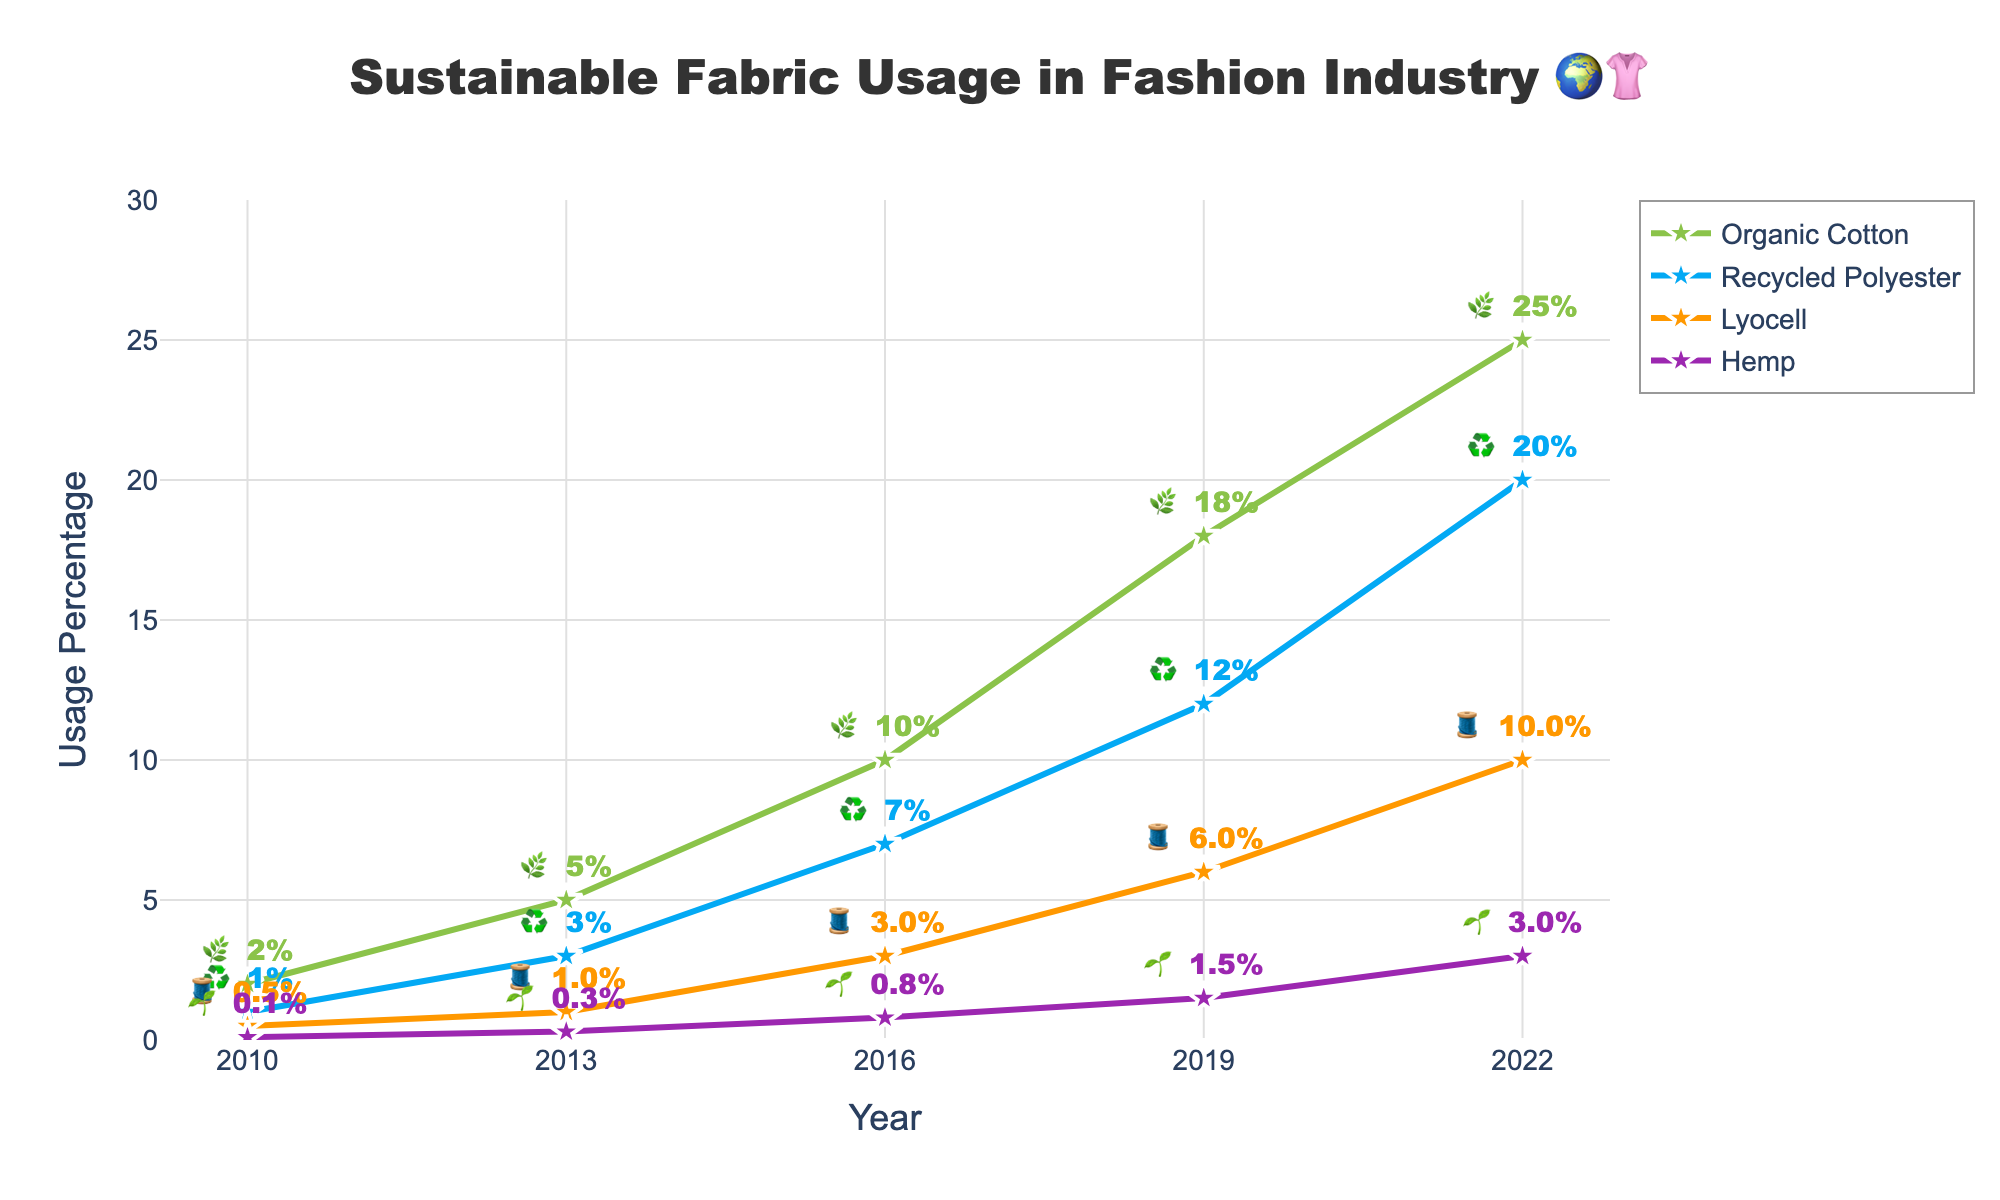what is the title of the chart? The title is positioned at the top center of the chart and reads 'Sustainable Fabric Usage in Fashion Industry 🌍👚'. So, the title clearly states the theme and context of the data presented.
Answer: 'Sustainable Fabric Usage in Fashion Industry 🌍👚' Which fabric has the highest percentage of usage in 2022? By examining the data labels and lines for 2022, we can see that Organic Cotton has the highest percentage at 25%.
Answer: Organic Cotton What is the percentage difference in Organic Cotton usage between 2013 and 2019? In 2013, Organic Cotton usage was 5%, and in 2019, it was 18%. The difference is calculated as 18% - 5%, which equals 13%.
Answer: 13% Rank the fabrics based on their usage in 2010 from highest to lowest Looking at the 2010 data points, the percentages are Organic Cotton at 2%, Recycled Polyester at 1%, Lyocell at 0.5%, and Hemp at 0.1%. Ranking these gives Organic Cotton > Recycled Polyester > Lyocell > Hemp.
Answer: Organic Cotton, Recycled Polyester, Lyocell, Hemp How did the usage of Hemp change from 2010 to 2022? The usage of Hemp increased from 0.1% in 2010 to 3% in 2022. This change indicates a 2.9% increase over 12 years.
Answer: Increased by 2.9% Between which consecutive years was the largest increase in Recycled Polyester usage? By checking the percentage increases year-by-year: 2010-2013 (2%), 2013-2016 (4%), 2016-2019 (5%), and 2019-2022 (8%). The largest increase of 8% occurred between 2019 and 2022.
Answer: 2019 and 2022 What is the average usage percentage of Lyocell across all given years? The percentage values for Lyocell are 0.5%, 1%, 3%, 6%, and 10%. Summing these gives 20.5%, and dividing by 5 years results in an average of 4.1%.
Answer: 4.1% Which fabric showed the most consistent growth over the period? By evaluating the lines and their consistency in slope, it appears that Organic Cotton consistently increases with significant and steady increments across all years.
Answer: Organic Cotton Did any fabric usage percentage decrease between any two consecutive years? Observing the lines on the plot, all fabric percentages continuously increase, indicating no decreases over the years presented.
Answer: No Combine the usage percentages of Lyocell and Hemp in 2016. What is the total? For 2016, Lyocell usage is 3%, and Hemp usage is 0.8%. The combined total is 3% + 0.8% = 3.8%.
Answer: 3.8% 